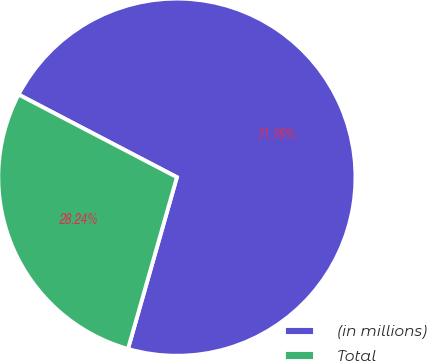Convert chart. <chart><loc_0><loc_0><loc_500><loc_500><pie_chart><fcel>(in millions)<fcel>Total<nl><fcel>71.76%<fcel>28.24%<nl></chart> 